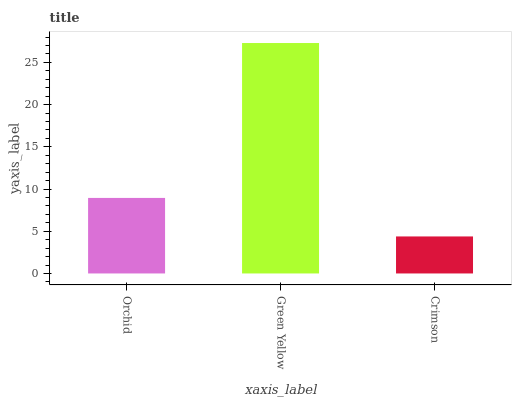Is Crimson the minimum?
Answer yes or no. Yes. Is Green Yellow the maximum?
Answer yes or no. Yes. Is Green Yellow the minimum?
Answer yes or no. No. Is Crimson the maximum?
Answer yes or no. No. Is Green Yellow greater than Crimson?
Answer yes or no. Yes. Is Crimson less than Green Yellow?
Answer yes or no. Yes. Is Crimson greater than Green Yellow?
Answer yes or no. No. Is Green Yellow less than Crimson?
Answer yes or no. No. Is Orchid the high median?
Answer yes or no. Yes. Is Orchid the low median?
Answer yes or no. Yes. Is Crimson the high median?
Answer yes or no. No. Is Crimson the low median?
Answer yes or no. No. 